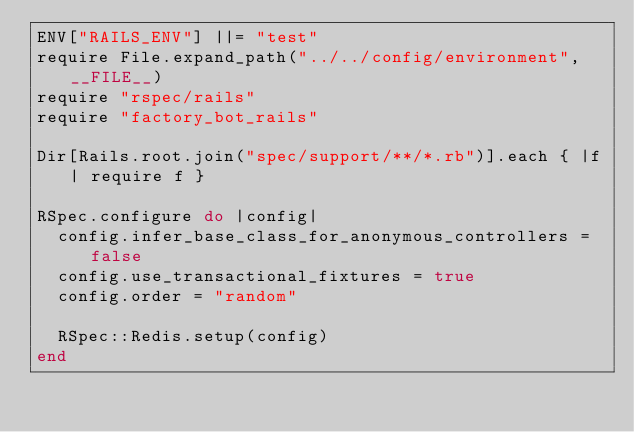Convert code to text. <code><loc_0><loc_0><loc_500><loc_500><_Ruby_>ENV["RAILS_ENV"] ||= "test"
require File.expand_path("../../config/environment", __FILE__)
require "rspec/rails"
require "factory_bot_rails"

Dir[Rails.root.join("spec/support/**/*.rb")].each { |f| require f }

RSpec.configure do |config|
  config.infer_base_class_for_anonymous_controllers = false
  config.use_transactional_fixtures = true
  config.order = "random"

  RSpec::Redis.setup(config)
end
</code> 